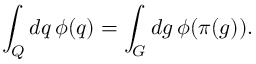<formula> <loc_0><loc_0><loc_500><loc_500>\int _ { Q } d q \, \phi ( q ) = \int _ { G } d g \, \phi ( \pi ( g ) ) .</formula> 